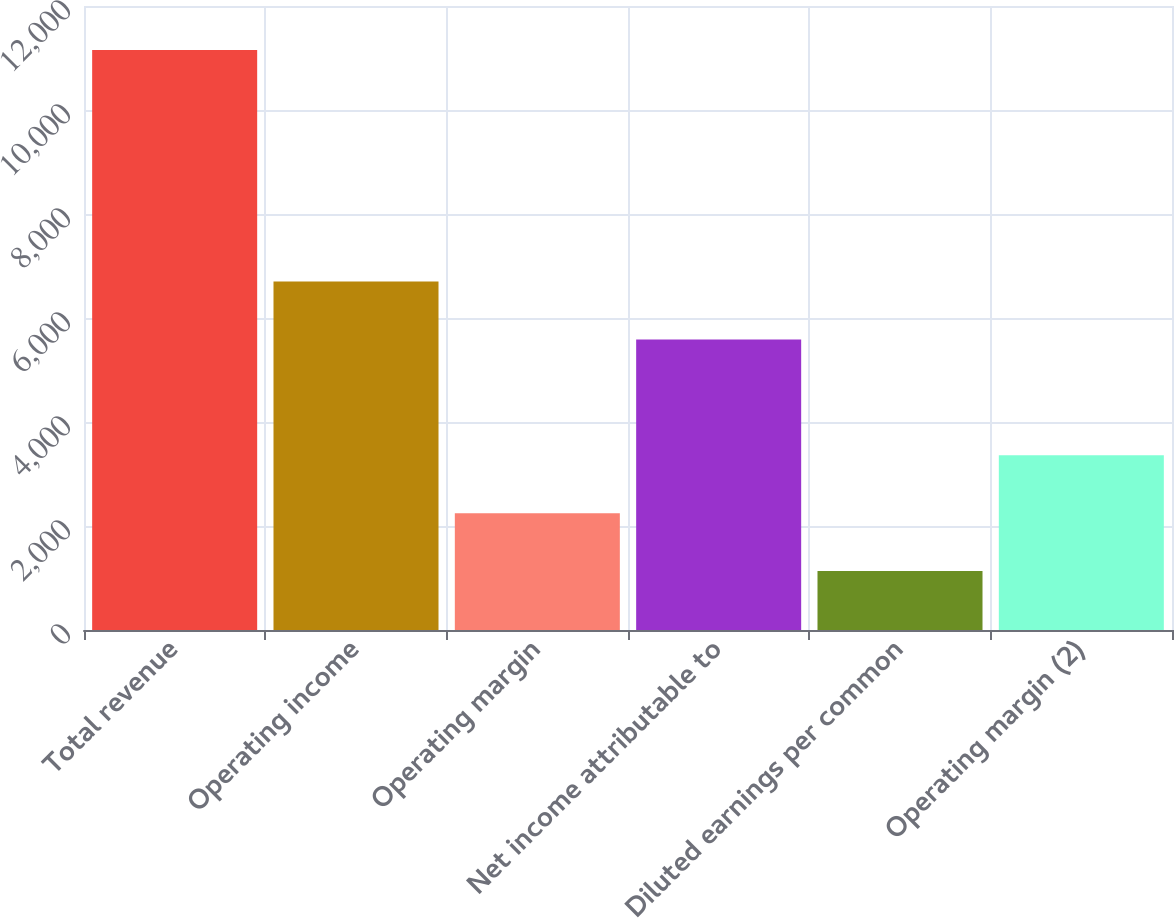Convert chart. <chart><loc_0><loc_0><loc_500><loc_500><bar_chart><fcel>Total revenue<fcel>Operating income<fcel>Operating margin<fcel>Net income attributable to<fcel>Diluted earnings per common<fcel>Operating margin (2)<nl><fcel>11155<fcel>6700.64<fcel>2246.24<fcel>5587.04<fcel>1132.64<fcel>3359.84<nl></chart> 